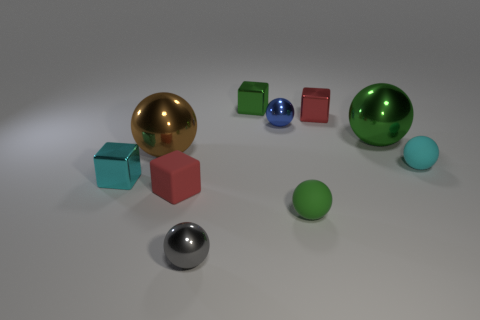Is the number of red blocks that are behind the tiny cyan rubber ball less than the number of balls?
Offer a terse response. Yes. There is a red thing to the left of the gray metal object; is its size the same as the tiny green metal cube?
Your response must be concise. Yes. What number of tiny shiny objects are behind the gray metallic object and right of the small cyan shiny object?
Your response must be concise. 3. There is a metallic sphere that is in front of the cyan thing on the left side of the red rubber object; how big is it?
Make the answer very short. Small. Is the number of small green metallic cubes that are left of the small gray metallic object less than the number of tiny green metallic blocks left of the cyan rubber thing?
Make the answer very short. Yes. There is a metallic cube that is in front of the tiny cyan rubber ball; is it the same color as the small rubber object that is behind the matte block?
Provide a short and direct response. Yes. There is a thing that is to the left of the small matte block and in front of the big brown metallic object; what material is it?
Make the answer very short. Metal. Are any small gray metallic balls visible?
Make the answer very short. Yes. There is a large green object that is the same material as the gray sphere; what shape is it?
Provide a succinct answer. Sphere. There is a tiny red rubber object; does it have the same shape as the big object that is on the right side of the gray ball?
Offer a terse response. No. 